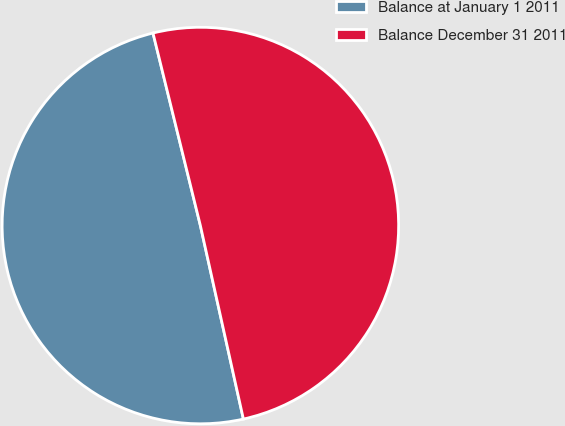Convert chart. <chart><loc_0><loc_0><loc_500><loc_500><pie_chart><fcel>Balance at January 1 2011<fcel>Balance December 31 2011<nl><fcel>49.64%<fcel>50.36%<nl></chart> 